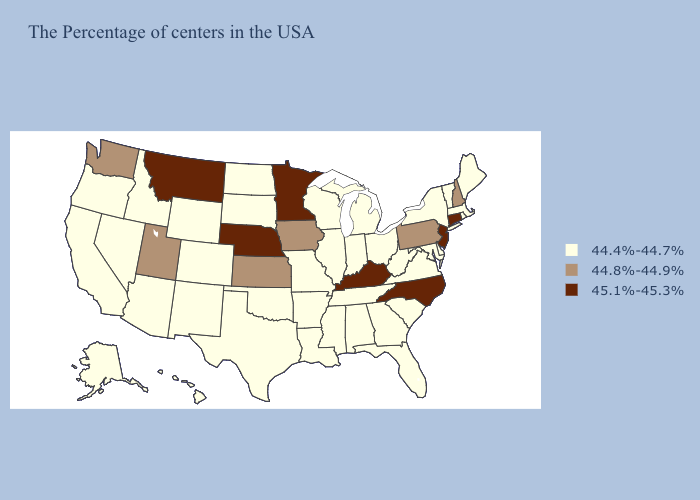Does Ohio have the highest value in the USA?
Write a very short answer. No. What is the lowest value in the Northeast?
Be succinct. 44.4%-44.7%. Does the first symbol in the legend represent the smallest category?
Keep it brief. Yes. Does Texas have a higher value than Utah?
Be succinct. No. How many symbols are there in the legend?
Write a very short answer. 3. Name the states that have a value in the range 45.1%-45.3%?
Keep it brief. Connecticut, New Jersey, North Carolina, Kentucky, Minnesota, Nebraska, Montana. Does Nebraska have the highest value in the USA?
Quick response, please. Yes. How many symbols are there in the legend?
Concise answer only. 3. Which states hav the highest value in the MidWest?
Concise answer only. Minnesota, Nebraska. What is the value of Alaska?
Quick response, please. 44.4%-44.7%. Name the states that have a value in the range 44.8%-44.9%?
Short answer required. New Hampshire, Pennsylvania, Iowa, Kansas, Utah, Washington. Does Montana have the same value as Kentucky?
Keep it brief. Yes. Among the states that border South Dakota , does Nebraska have the highest value?
Write a very short answer. Yes. How many symbols are there in the legend?
Be succinct. 3. Does the map have missing data?
Answer briefly. No. 